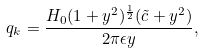<formula> <loc_0><loc_0><loc_500><loc_500>q _ { k } = \frac { H _ { 0 } ( 1 + y ^ { 2 } ) ^ { \frac { 1 } { 2 } } ( \tilde { c } + y ^ { 2 } ) } { 2 \pi \epsilon y } ,</formula> 